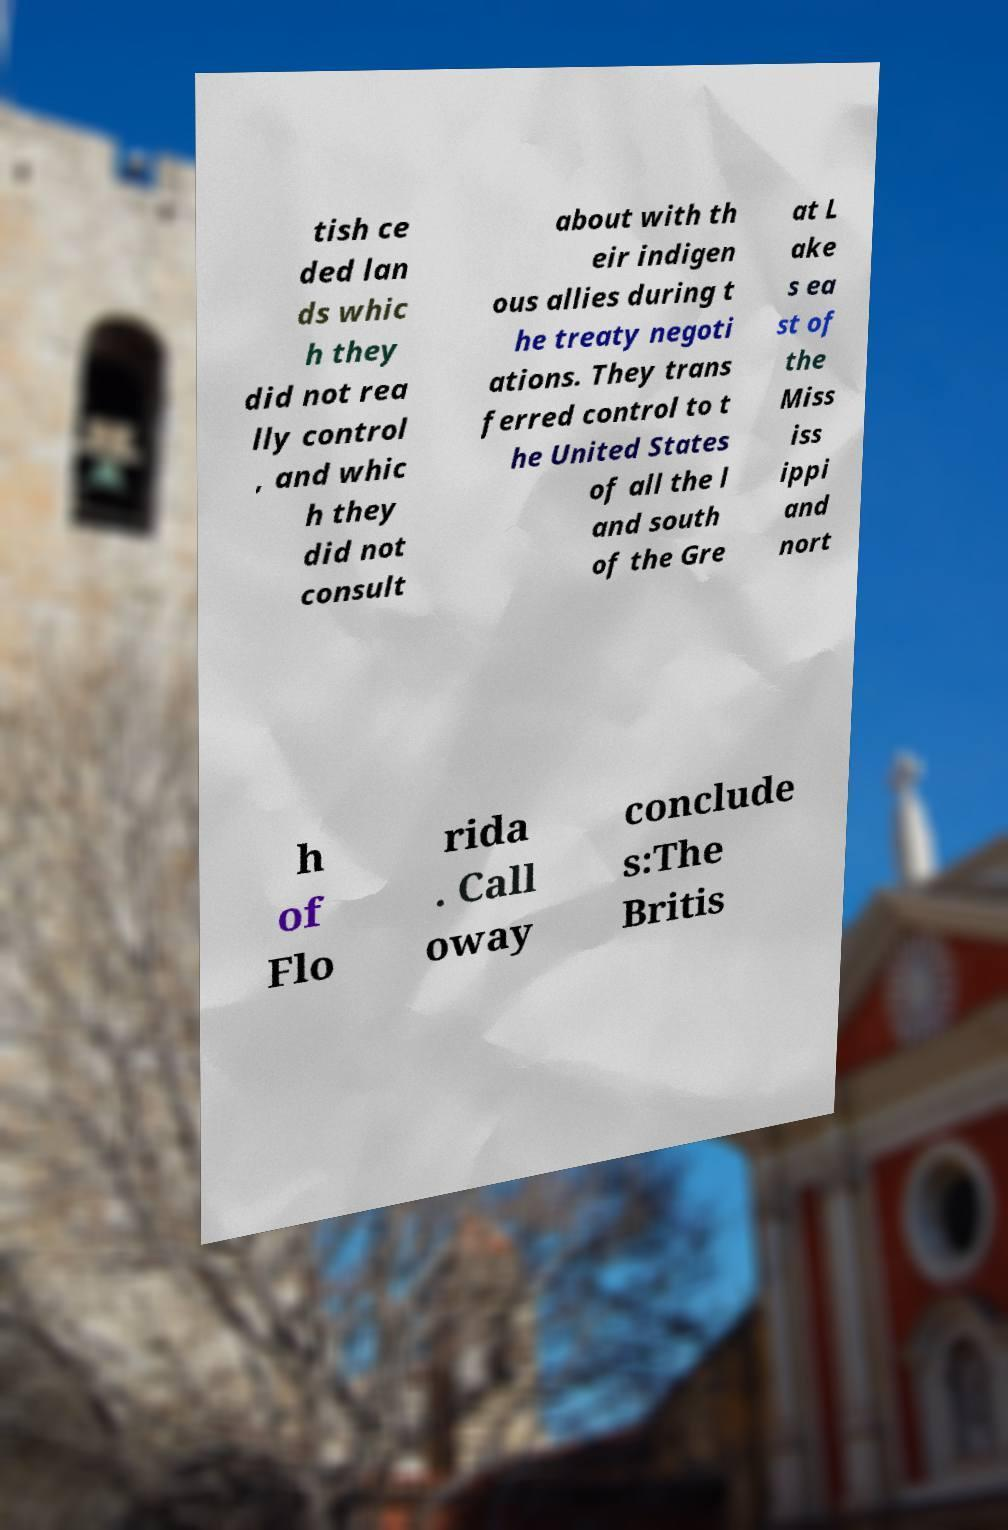For documentation purposes, I need the text within this image transcribed. Could you provide that? tish ce ded lan ds whic h they did not rea lly control , and whic h they did not consult about with th eir indigen ous allies during t he treaty negoti ations. They trans ferred control to t he United States of all the l and south of the Gre at L ake s ea st of the Miss iss ippi and nort h of Flo rida . Call oway conclude s:The Britis 